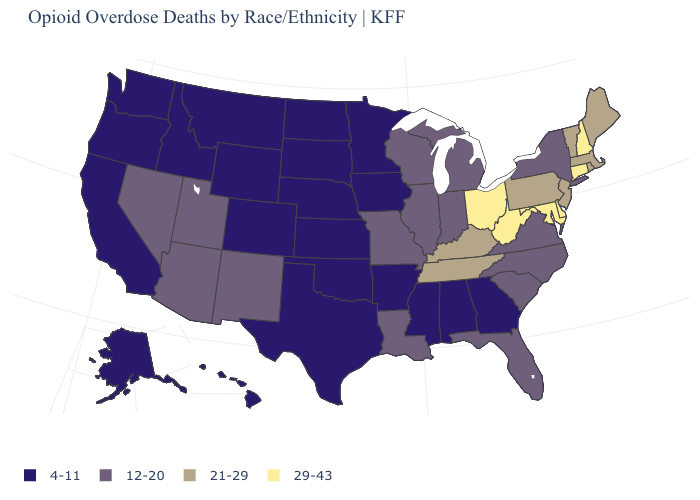What is the value of North Carolina?
Quick response, please. 12-20. Name the states that have a value in the range 12-20?
Quick response, please. Arizona, Florida, Illinois, Indiana, Louisiana, Michigan, Missouri, Nevada, New Mexico, New York, North Carolina, South Carolina, Utah, Virginia, Wisconsin. What is the value of Vermont?
Keep it brief. 21-29. What is the value of Iowa?
Be succinct. 4-11. What is the value of Oklahoma?
Be succinct. 4-11. Which states have the lowest value in the Northeast?
Write a very short answer. New York. What is the value of South Dakota?
Short answer required. 4-11. Name the states that have a value in the range 21-29?
Concise answer only. Kentucky, Maine, Massachusetts, New Jersey, Pennsylvania, Rhode Island, Tennessee, Vermont. Which states have the lowest value in the USA?
Keep it brief. Alabama, Alaska, Arkansas, California, Colorado, Georgia, Hawaii, Idaho, Iowa, Kansas, Minnesota, Mississippi, Montana, Nebraska, North Dakota, Oklahoma, Oregon, South Dakota, Texas, Washington, Wyoming. Among the states that border Indiana , does Kentucky have the lowest value?
Write a very short answer. No. What is the value of Nevada?
Short answer required. 12-20. What is the value of Maine?
Short answer required. 21-29. Name the states that have a value in the range 12-20?
Keep it brief. Arizona, Florida, Illinois, Indiana, Louisiana, Michigan, Missouri, Nevada, New Mexico, New York, North Carolina, South Carolina, Utah, Virginia, Wisconsin. Does Wisconsin have the highest value in the USA?
Give a very brief answer. No. What is the value of Washington?
Concise answer only. 4-11. 